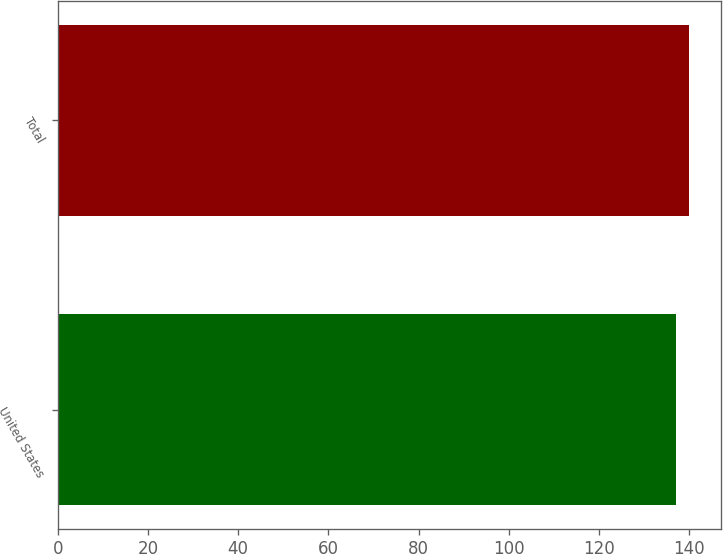Convert chart to OTSL. <chart><loc_0><loc_0><loc_500><loc_500><bar_chart><fcel>United States<fcel>Total<nl><fcel>137<fcel>140<nl></chart> 